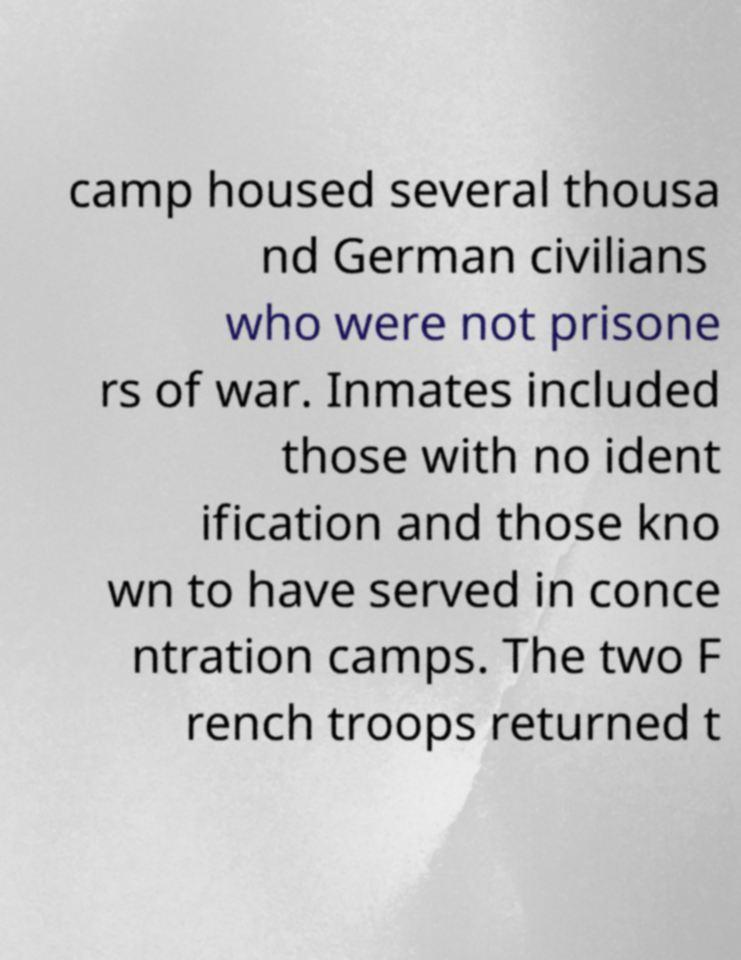Can you accurately transcribe the text from the provided image for me? camp housed several thousa nd German civilians who were not prisone rs of war. Inmates included those with no ident ification and those kno wn to have served in conce ntration camps. The two F rench troops returned t 